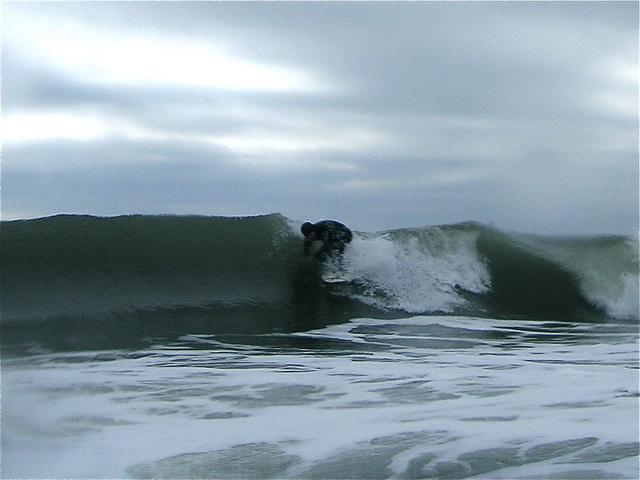What is the person doing?
Concise answer only. Surfing. Is this an iceberg?
Keep it brief. No. What type of vessel is shown?
Short answer required. Surfboard. What is in the water?
Keep it brief. Surfer. What season is this?
Be succinct. Summer. What is the condition of the water?
Write a very short answer. Wavy. 